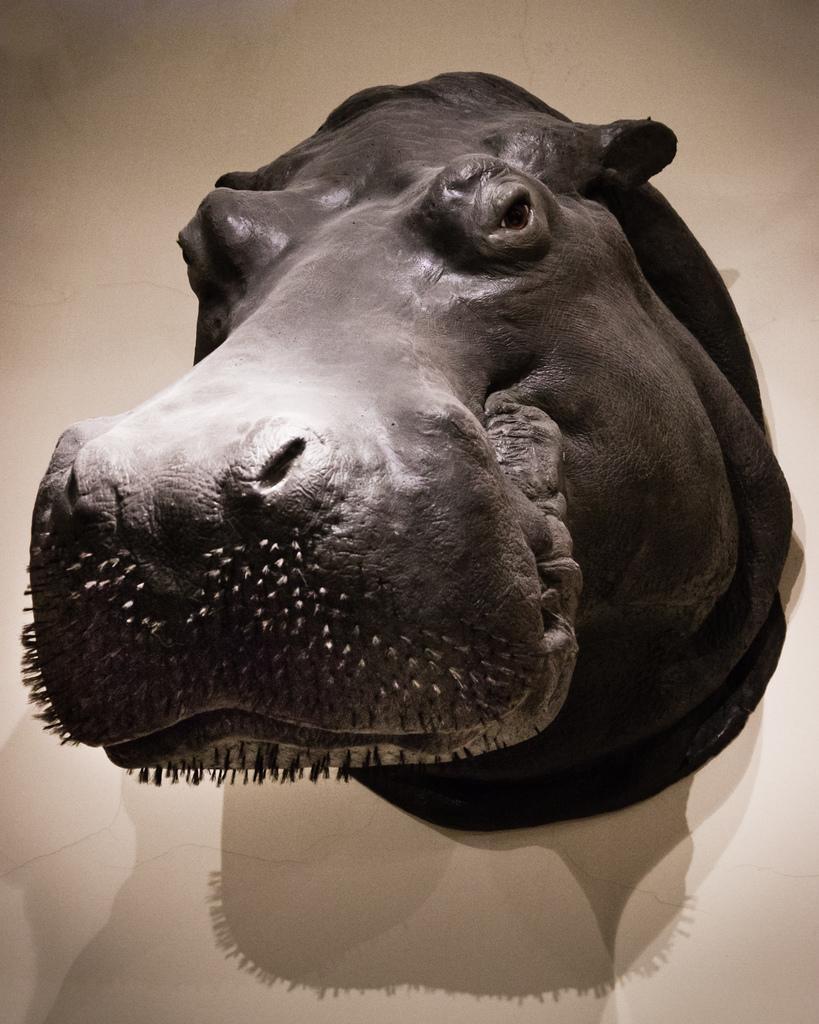Could you give a brief overview of what you see in this image? In this image there is a sculpture of an animal attached to the wall. 